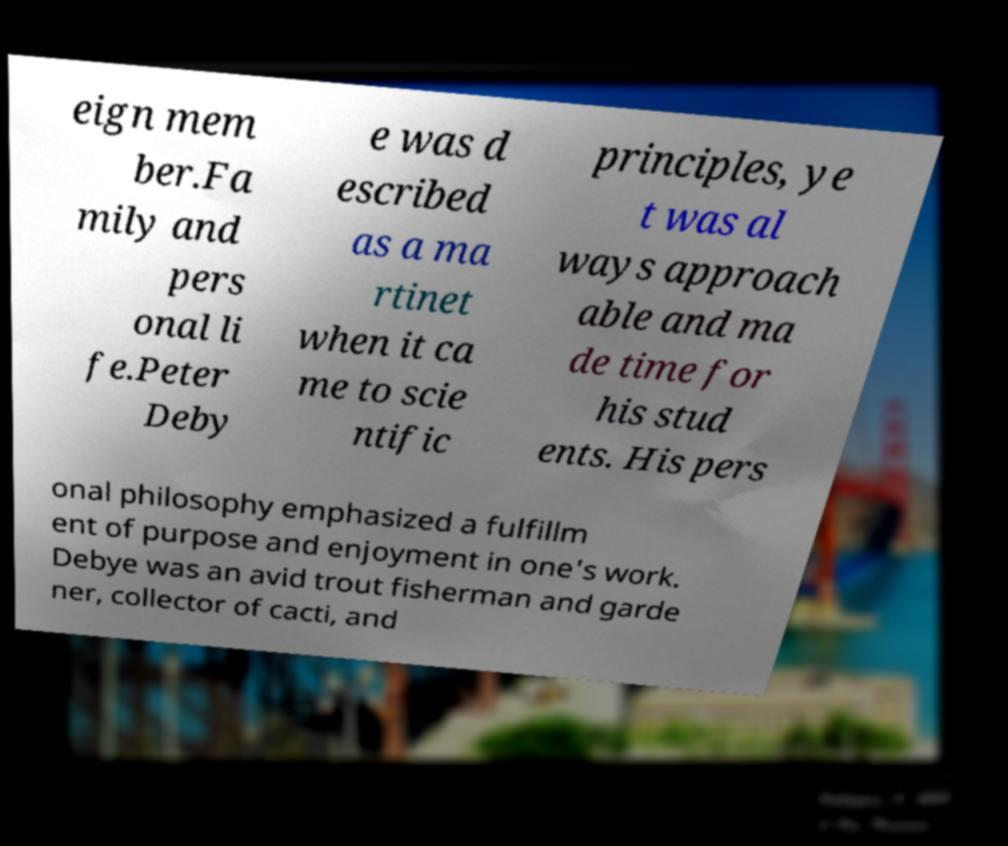Please read and relay the text visible in this image. What does it say? eign mem ber.Fa mily and pers onal li fe.Peter Deby e was d escribed as a ma rtinet when it ca me to scie ntific principles, ye t was al ways approach able and ma de time for his stud ents. His pers onal philosophy emphasized a fulfillm ent of purpose and enjoyment in one's work. Debye was an avid trout fisherman and garde ner, collector of cacti, and 